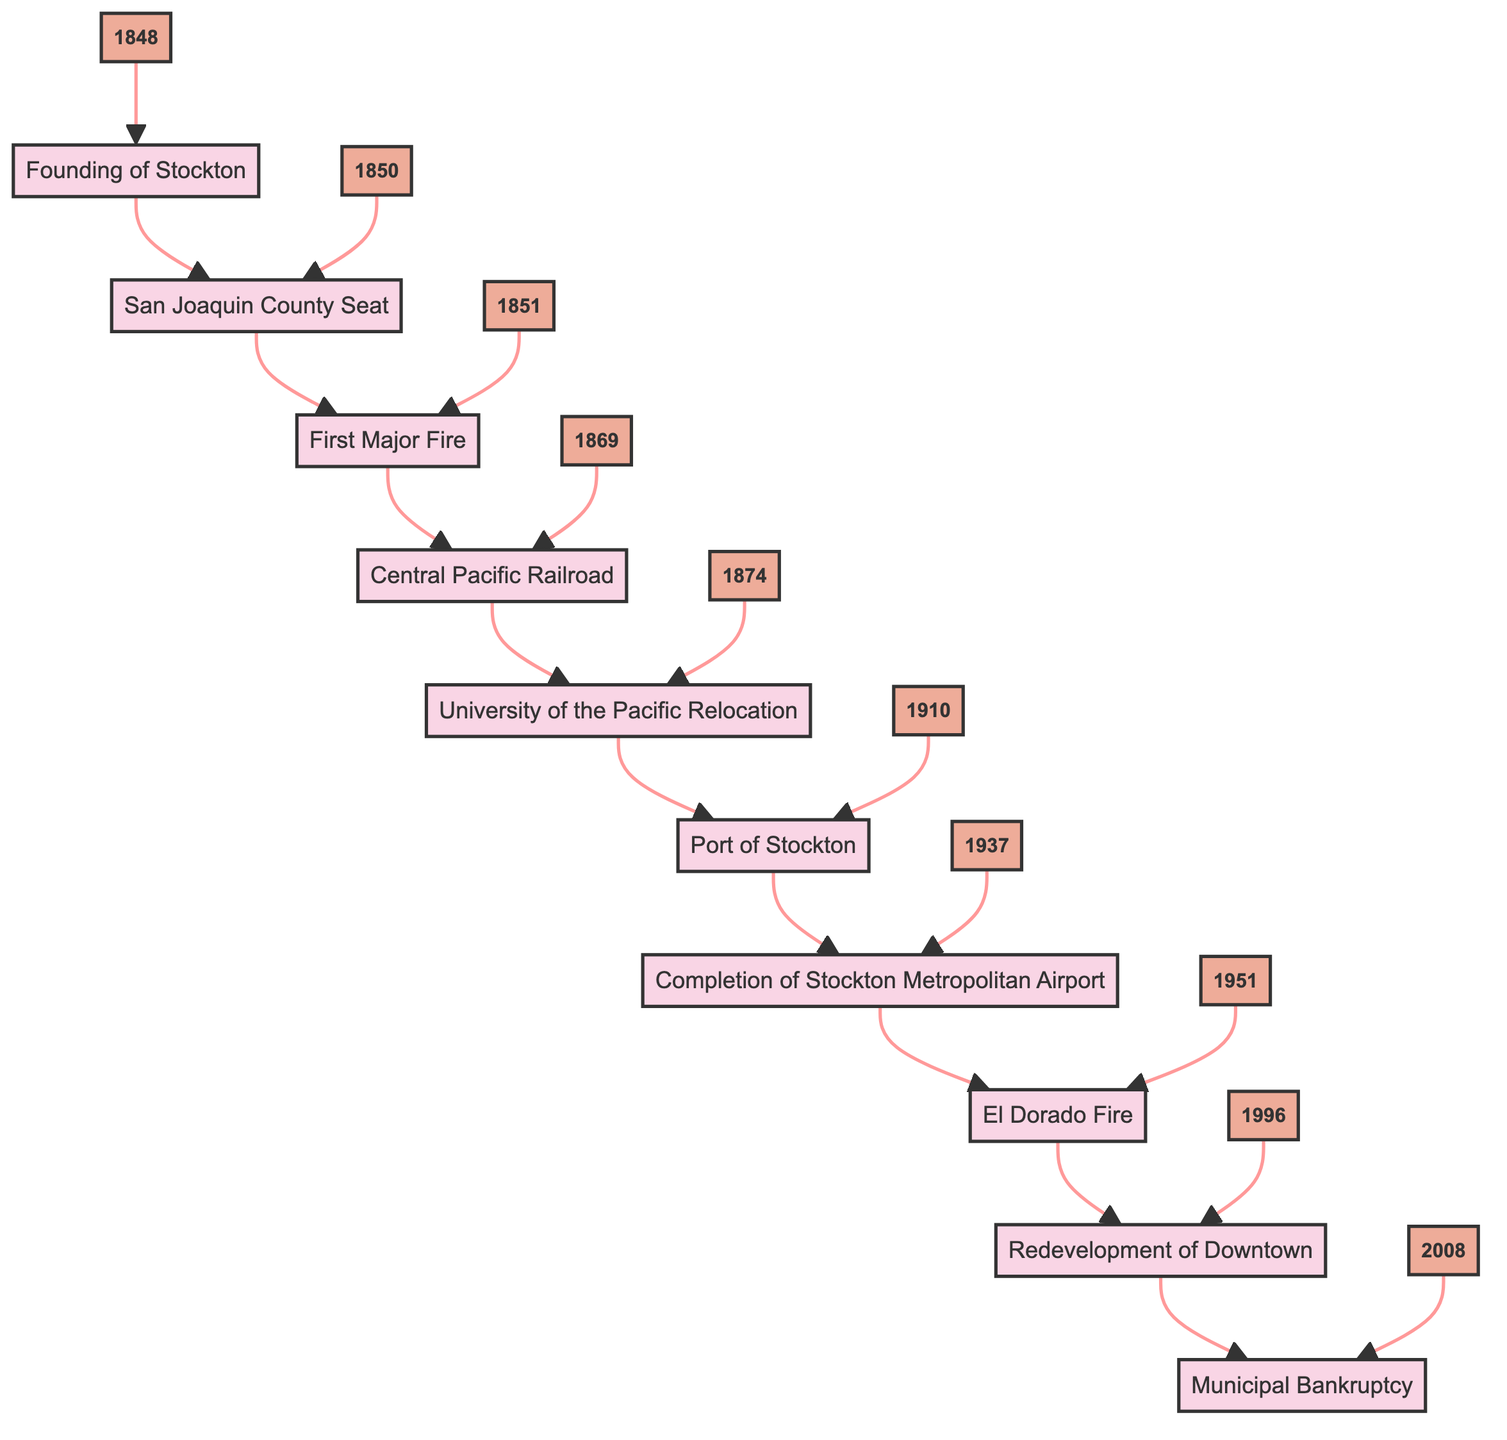What event is associated with the year 1848? The year 1848 is connected to the event "Founding of Stockton," which is the first event listed in the flow chart.
Answer: Founding of Stockton Which event follows the first major fire? The first major fire occurs in 1851. The event that follows it, according to the flow of the chart, is "Central Pacific Railroad."
Answer: Central Pacific Railroad How many events are listed in the flow chart? The flow chart lists a total of 10 events, as indicated by the 10 different nodes representing each key historical event.
Answer: 10 What is the last event in the timeline? The last event in the timeline is "Municipal Bankruptcy," which is the final node in the flow chart, indicating it is the most recent event.
Answer: Municipal Bankruptcy Which year had the completion of Stockton Metropolitan Airport? The completion of Stockton Metropolitan Airport is recorded as having occurred in 1937, which is indicated by the corresponding node connected to that event.
Answer: 1937 What event took place directly before the opening of the Port of Stockton? The event that directly precedes the opening of the Port of Stockton in 1910 is the "University of the Pacific Relocation," which occurs in the year 1874.
Answer: University of the Pacific Relocation Which event corresponds to the year 2008? The year 2008 corresponds to the event "Municipal Bankruptcy," which is the last event in the flow chart timeline.
Answer: Municipal Bankruptcy What historical event led to the establishment of the first volunteer fire department? The event that led to the establishment of the first volunteer fire department is "First Major Fire," which occurred in 1851.
Answer: First Major Fire What is the relationship between the Central Pacific Railroad and population growth in Stockton? The Central Pacific Railroad in 1869 is described as boosting trade and population growth, indicating a direct relationship where improved transportation led to increased population.
Answer: Boosting trade and population growth 